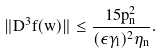Convert formula to latex. <formula><loc_0><loc_0><loc_500><loc_500>\| D ^ { 3 } f ( w ) \| \leq \frac { 1 5 p _ { n } ^ { 2 } } { ( \epsilon \gamma _ { l } ) ^ { 2 } \eta _ { n } } .</formula> 